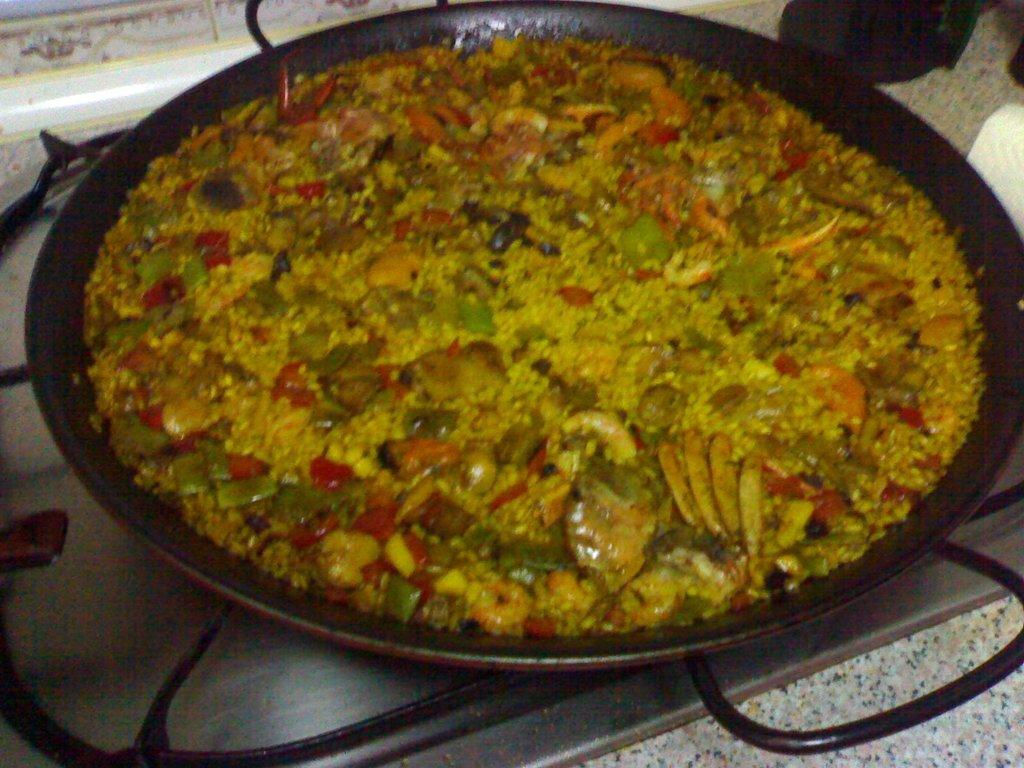What is in the pan that is visible in the image? There is a pan containing food in the image. Where is the pan located in the image? The pan is placed on a stove in the image. What surface is visible at the bottom of the image? There is a countertop at the bottom of the image. What type of boundary can be seen between the pan and the stove in the image? There is no boundary visible between the pan and the stove in the image; they are in direct contact with each other. 